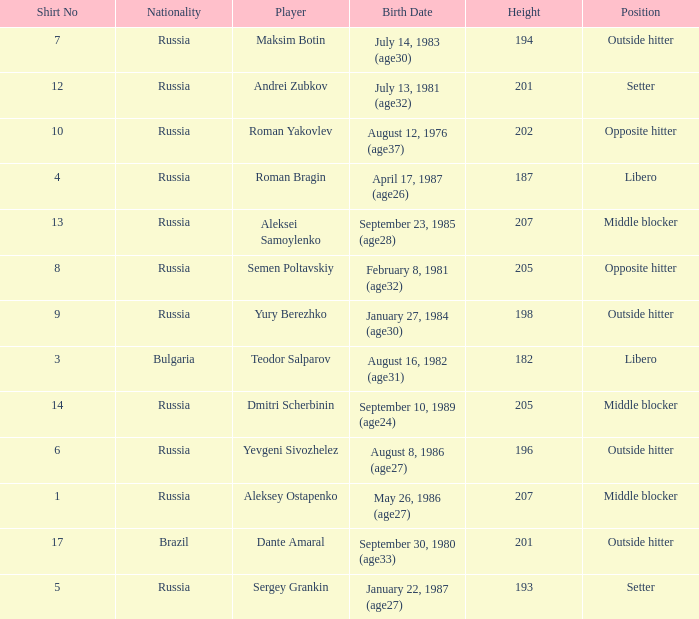What is Maksim Botin's position?  Outside hitter. 